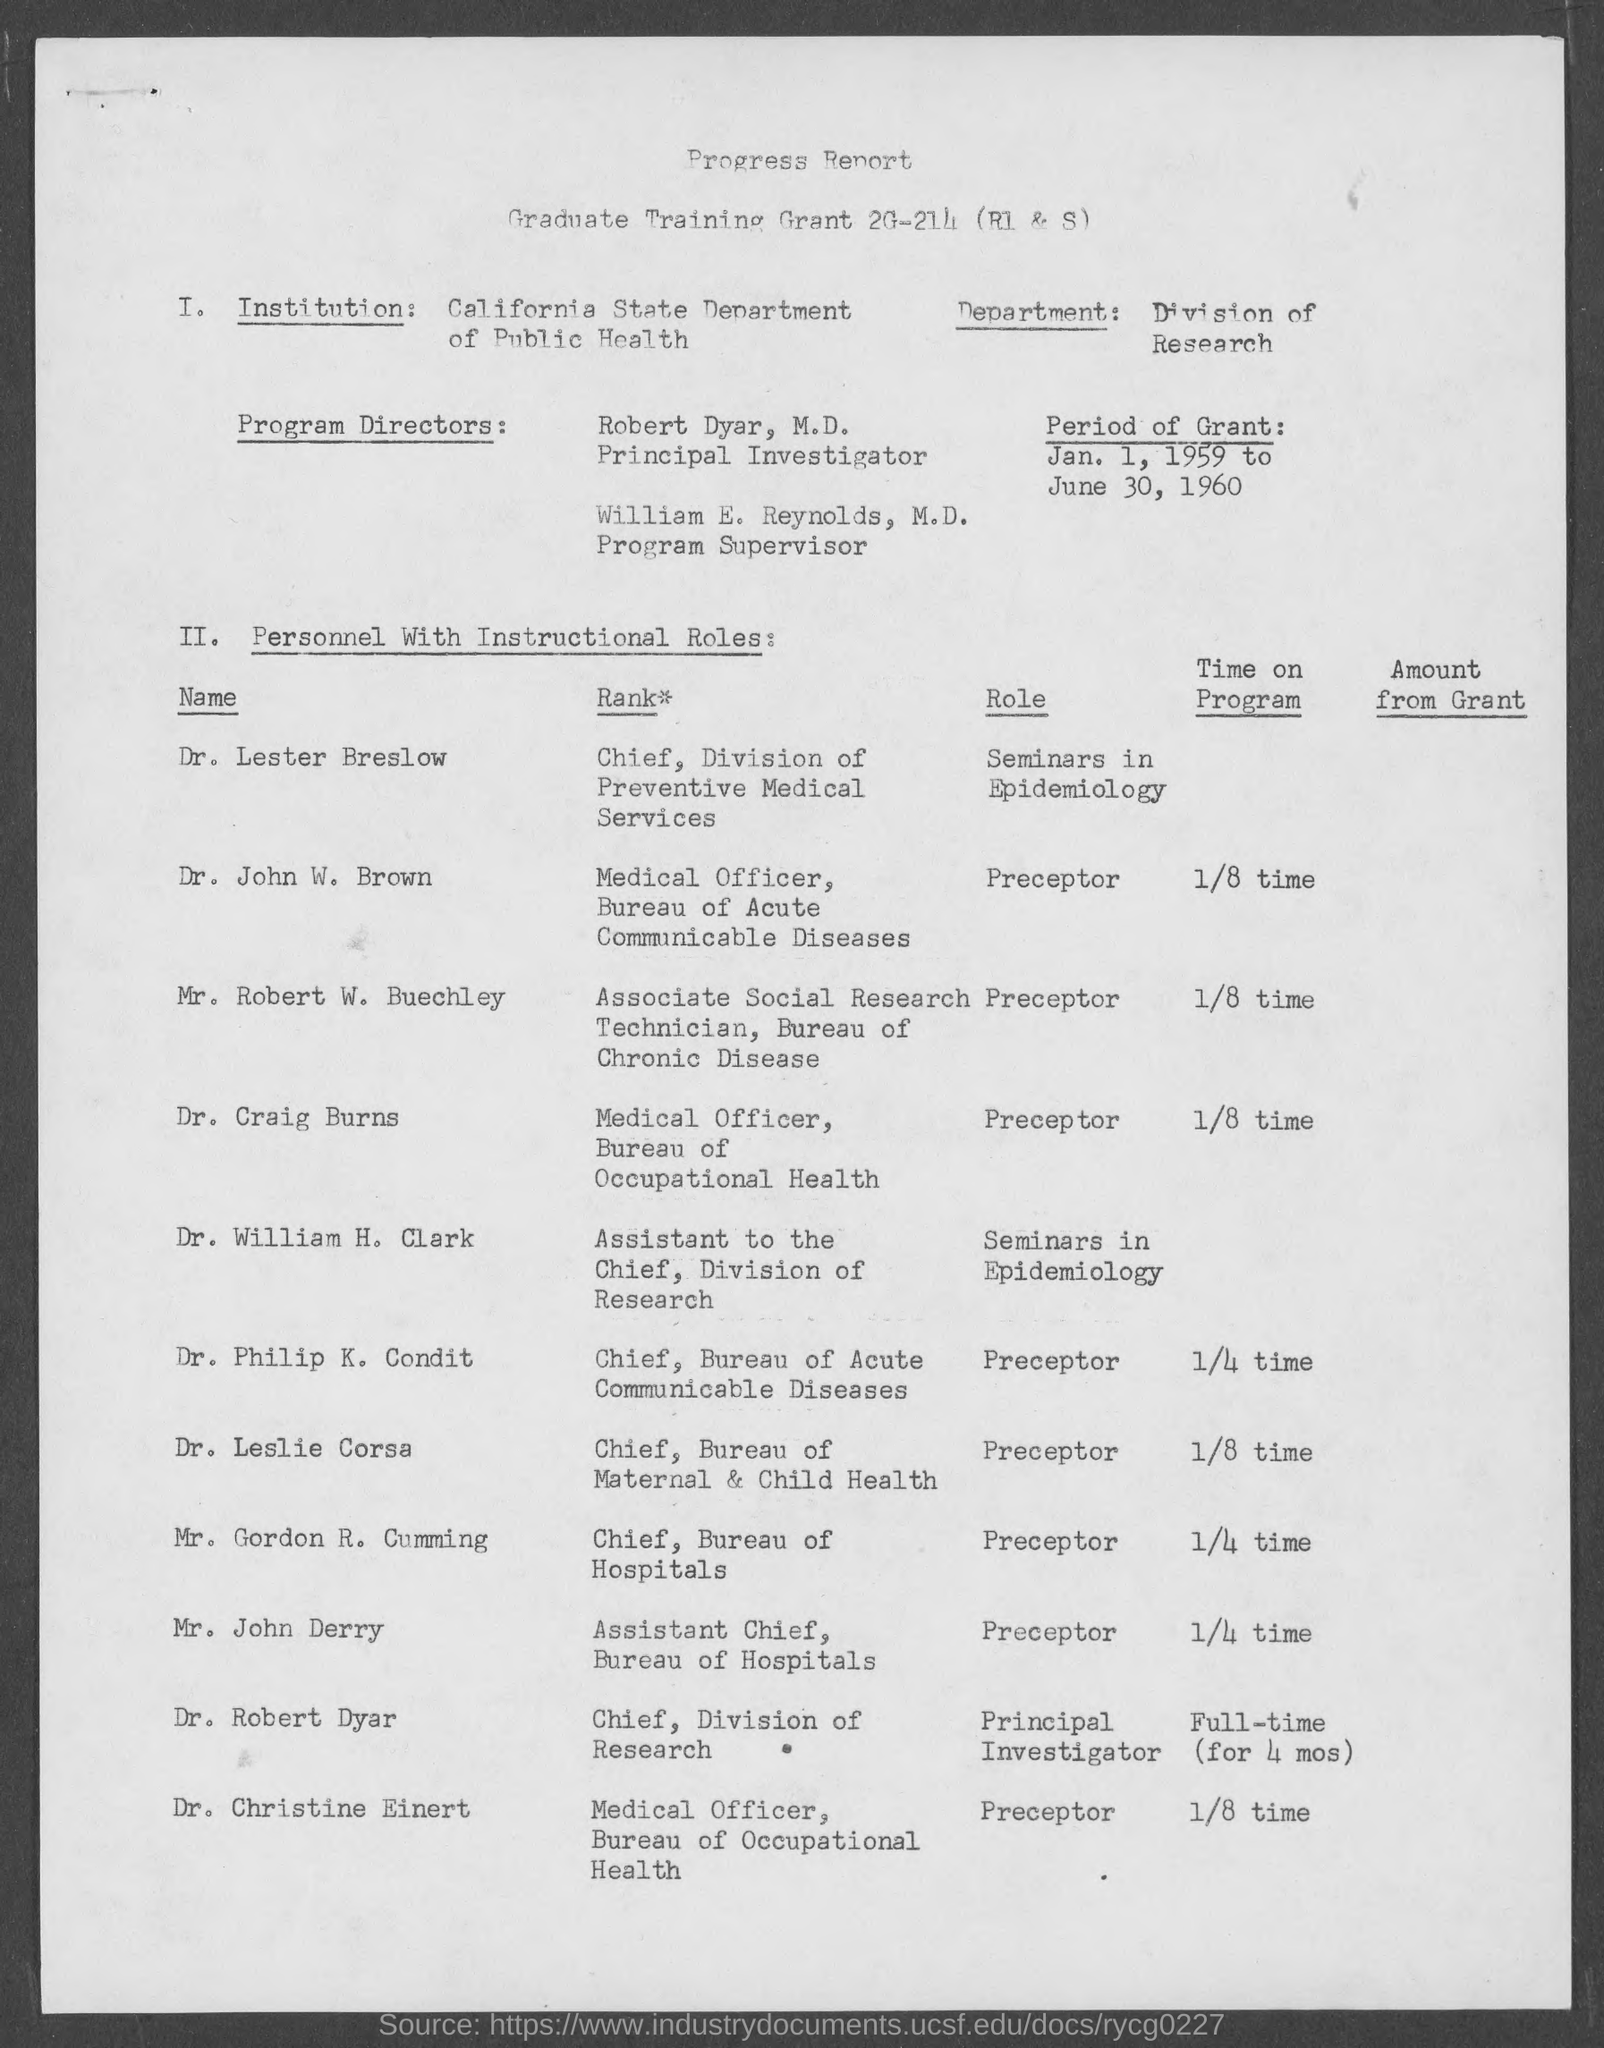Identify some key points in this picture. The Medical Officer for the Bureau of Acute Communicable Diseases is Dr. John W. Brown. Dr. Lester Breslow is the Chief of the Division of Preventive Medical Services, holding a high rank within that organization. According to the document, Robert Dyar is the Principal Investigator. The period of Grant as mentioned in the document is from January 1, 1959 to June 30, 1960. The Program Supervisor mentioned in the document is William E. Reynolds, M.D. 